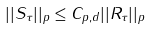<formula> <loc_0><loc_0><loc_500><loc_500>| | S _ { \tau } | | _ { p } \leq C _ { p , d } | | R _ { \tau } | | _ { p }</formula> 